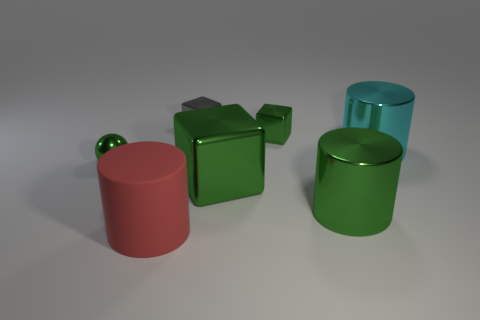There is a cyan object that is the same size as the rubber cylinder; what is its material?
Give a very brief answer. Metal. Are the green thing that is to the left of the big matte object and the tiny green object that is to the right of the big red cylinder made of the same material?
Provide a short and direct response. Yes. There is a cyan metallic thing that is the same size as the matte cylinder; what shape is it?
Ensure brevity in your answer.  Cylinder. How many other things are there of the same color as the big matte thing?
Provide a succinct answer. 0. What is the color of the large object that is behind the tiny shiny ball?
Ensure brevity in your answer.  Cyan. What number of other objects are the same material as the small gray object?
Offer a terse response. 5. Are there more small green blocks that are in front of the big green metal cylinder than green shiny cylinders left of the large red cylinder?
Give a very brief answer. No. There is a large green metallic cube; how many cyan shiny objects are in front of it?
Provide a succinct answer. 0. Do the large cyan cylinder and the green block to the left of the small green metallic cube have the same material?
Your response must be concise. Yes. Is there any other thing that has the same shape as the cyan thing?
Your answer should be very brief. Yes. 